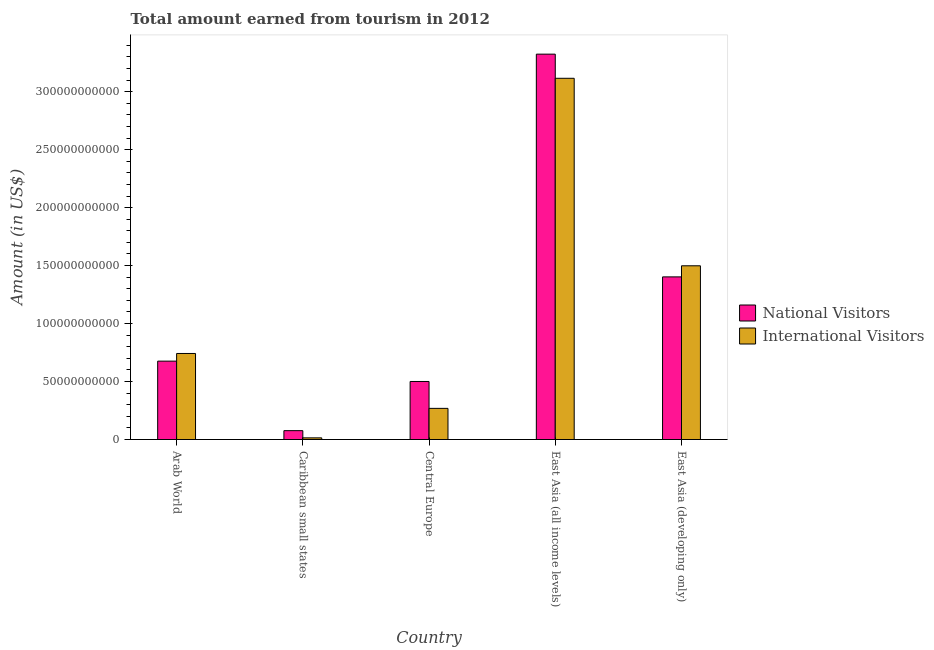How many groups of bars are there?
Offer a very short reply. 5. Are the number of bars on each tick of the X-axis equal?
Provide a succinct answer. Yes. How many bars are there on the 2nd tick from the left?
Provide a short and direct response. 2. What is the label of the 2nd group of bars from the left?
Keep it short and to the point. Caribbean small states. In how many cases, is the number of bars for a given country not equal to the number of legend labels?
Your response must be concise. 0. What is the amount earned from national visitors in East Asia (all income levels)?
Your answer should be very brief. 3.32e+11. Across all countries, what is the maximum amount earned from international visitors?
Offer a terse response. 3.12e+11. Across all countries, what is the minimum amount earned from international visitors?
Give a very brief answer. 1.44e+09. In which country was the amount earned from international visitors maximum?
Ensure brevity in your answer.  East Asia (all income levels). In which country was the amount earned from national visitors minimum?
Ensure brevity in your answer.  Caribbean small states. What is the total amount earned from national visitors in the graph?
Keep it short and to the point. 5.98e+11. What is the difference between the amount earned from international visitors in Arab World and that in East Asia (developing only)?
Keep it short and to the point. -7.56e+1. What is the difference between the amount earned from national visitors in East Asia (all income levels) and the amount earned from international visitors in Central Europe?
Give a very brief answer. 3.05e+11. What is the average amount earned from national visitors per country?
Provide a succinct answer. 1.20e+11. What is the difference between the amount earned from international visitors and amount earned from national visitors in East Asia (developing only)?
Provide a short and direct response. 9.57e+09. In how many countries, is the amount earned from national visitors greater than 330000000000 US$?
Your answer should be compact. 1. What is the ratio of the amount earned from international visitors in East Asia (all income levels) to that in East Asia (developing only)?
Your response must be concise. 2.08. Is the difference between the amount earned from national visitors in Arab World and East Asia (all income levels) greater than the difference between the amount earned from international visitors in Arab World and East Asia (all income levels)?
Your response must be concise. No. What is the difference between the highest and the second highest amount earned from international visitors?
Your response must be concise. 1.62e+11. What is the difference between the highest and the lowest amount earned from national visitors?
Offer a terse response. 3.25e+11. Is the sum of the amount earned from national visitors in Central Europe and East Asia (all income levels) greater than the maximum amount earned from international visitors across all countries?
Offer a terse response. Yes. What does the 1st bar from the left in Caribbean small states represents?
Give a very brief answer. National Visitors. What does the 2nd bar from the right in Central Europe represents?
Your answer should be compact. National Visitors. How many bars are there?
Make the answer very short. 10. Are all the bars in the graph horizontal?
Provide a short and direct response. No. How are the legend labels stacked?
Provide a succinct answer. Vertical. What is the title of the graph?
Offer a terse response. Total amount earned from tourism in 2012. What is the label or title of the X-axis?
Your answer should be very brief. Country. What is the Amount (in US$) of National Visitors in Arab World?
Ensure brevity in your answer.  6.76e+1. What is the Amount (in US$) of International Visitors in Arab World?
Offer a terse response. 7.42e+1. What is the Amount (in US$) in National Visitors in Caribbean small states?
Your response must be concise. 7.65e+09. What is the Amount (in US$) of International Visitors in Caribbean small states?
Offer a very short reply. 1.44e+09. What is the Amount (in US$) of National Visitors in Central Europe?
Provide a short and direct response. 5.01e+1. What is the Amount (in US$) in International Visitors in Central Europe?
Offer a terse response. 2.69e+1. What is the Amount (in US$) of National Visitors in East Asia (all income levels)?
Offer a terse response. 3.32e+11. What is the Amount (in US$) in International Visitors in East Asia (all income levels)?
Provide a short and direct response. 3.12e+11. What is the Amount (in US$) in National Visitors in East Asia (developing only)?
Keep it short and to the point. 1.40e+11. What is the Amount (in US$) in International Visitors in East Asia (developing only)?
Offer a very short reply. 1.50e+11. Across all countries, what is the maximum Amount (in US$) of National Visitors?
Your answer should be compact. 3.32e+11. Across all countries, what is the maximum Amount (in US$) in International Visitors?
Offer a very short reply. 3.12e+11. Across all countries, what is the minimum Amount (in US$) in National Visitors?
Your answer should be compact. 7.65e+09. Across all countries, what is the minimum Amount (in US$) of International Visitors?
Provide a short and direct response. 1.44e+09. What is the total Amount (in US$) of National Visitors in the graph?
Offer a very short reply. 5.98e+11. What is the total Amount (in US$) in International Visitors in the graph?
Offer a very short reply. 5.64e+11. What is the difference between the Amount (in US$) of National Visitors in Arab World and that in Caribbean small states?
Provide a succinct answer. 6.00e+1. What is the difference between the Amount (in US$) in International Visitors in Arab World and that in Caribbean small states?
Keep it short and to the point. 7.28e+1. What is the difference between the Amount (in US$) in National Visitors in Arab World and that in Central Europe?
Your answer should be very brief. 1.75e+1. What is the difference between the Amount (in US$) of International Visitors in Arab World and that in Central Europe?
Your answer should be compact. 4.73e+1. What is the difference between the Amount (in US$) in National Visitors in Arab World and that in East Asia (all income levels)?
Keep it short and to the point. -2.65e+11. What is the difference between the Amount (in US$) in International Visitors in Arab World and that in East Asia (all income levels)?
Your answer should be very brief. -2.37e+11. What is the difference between the Amount (in US$) of National Visitors in Arab World and that in East Asia (developing only)?
Your response must be concise. -7.26e+1. What is the difference between the Amount (in US$) in International Visitors in Arab World and that in East Asia (developing only)?
Make the answer very short. -7.56e+1. What is the difference between the Amount (in US$) in National Visitors in Caribbean small states and that in Central Europe?
Offer a very short reply. -4.24e+1. What is the difference between the Amount (in US$) in International Visitors in Caribbean small states and that in Central Europe?
Your answer should be very brief. -2.54e+1. What is the difference between the Amount (in US$) in National Visitors in Caribbean small states and that in East Asia (all income levels)?
Give a very brief answer. -3.25e+11. What is the difference between the Amount (in US$) in International Visitors in Caribbean small states and that in East Asia (all income levels)?
Your answer should be very brief. -3.10e+11. What is the difference between the Amount (in US$) in National Visitors in Caribbean small states and that in East Asia (developing only)?
Keep it short and to the point. -1.33e+11. What is the difference between the Amount (in US$) of International Visitors in Caribbean small states and that in East Asia (developing only)?
Your answer should be very brief. -1.48e+11. What is the difference between the Amount (in US$) of National Visitors in Central Europe and that in East Asia (all income levels)?
Your response must be concise. -2.82e+11. What is the difference between the Amount (in US$) in International Visitors in Central Europe and that in East Asia (all income levels)?
Your answer should be compact. -2.85e+11. What is the difference between the Amount (in US$) of National Visitors in Central Europe and that in East Asia (developing only)?
Give a very brief answer. -9.02e+1. What is the difference between the Amount (in US$) in International Visitors in Central Europe and that in East Asia (developing only)?
Your response must be concise. -1.23e+11. What is the difference between the Amount (in US$) of National Visitors in East Asia (all income levels) and that in East Asia (developing only)?
Offer a very short reply. 1.92e+11. What is the difference between the Amount (in US$) of International Visitors in East Asia (all income levels) and that in East Asia (developing only)?
Offer a terse response. 1.62e+11. What is the difference between the Amount (in US$) of National Visitors in Arab World and the Amount (in US$) of International Visitors in Caribbean small states?
Offer a very short reply. 6.62e+1. What is the difference between the Amount (in US$) in National Visitors in Arab World and the Amount (in US$) in International Visitors in Central Europe?
Make the answer very short. 4.07e+1. What is the difference between the Amount (in US$) in National Visitors in Arab World and the Amount (in US$) in International Visitors in East Asia (all income levels)?
Make the answer very short. -2.44e+11. What is the difference between the Amount (in US$) in National Visitors in Arab World and the Amount (in US$) in International Visitors in East Asia (developing only)?
Provide a succinct answer. -8.22e+1. What is the difference between the Amount (in US$) of National Visitors in Caribbean small states and the Amount (in US$) of International Visitors in Central Europe?
Offer a terse response. -1.92e+1. What is the difference between the Amount (in US$) of National Visitors in Caribbean small states and the Amount (in US$) of International Visitors in East Asia (all income levels)?
Offer a very short reply. -3.04e+11. What is the difference between the Amount (in US$) of National Visitors in Caribbean small states and the Amount (in US$) of International Visitors in East Asia (developing only)?
Provide a short and direct response. -1.42e+11. What is the difference between the Amount (in US$) in National Visitors in Central Europe and the Amount (in US$) in International Visitors in East Asia (all income levels)?
Offer a terse response. -2.61e+11. What is the difference between the Amount (in US$) in National Visitors in Central Europe and the Amount (in US$) in International Visitors in East Asia (developing only)?
Offer a terse response. -9.98e+1. What is the difference between the Amount (in US$) of National Visitors in East Asia (all income levels) and the Amount (in US$) of International Visitors in East Asia (developing only)?
Keep it short and to the point. 1.83e+11. What is the average Amount (in US$) in National Visitors per country?
Ensure brevity in your answer.  1.20e+11. What is the average Amount (in US$) of International Visitors per country?
Provide a succinct answer. 1.13e+11. What is the difference between the Amount (in US$) of National Visitors and Amount (in US$) of International Visitors in Arab World?
Offer a terse response. -6.60e+09. What is the difference between the Amount (in US$) of National Visitors and Amount (in US$) of International Visitors in Caribbean small states?
Your answer should be very brief. 6.21e+09. What is the difference between the Amount (in US$) in National Visitors and Amount (in US$) in International Visitors in Central Europe?
Your response must be concise. 2.32e+1. What is the difference between the Amount (in US$) in National Visitors and Amount (in US$) in International Visitors in East Asia (all income levels)?
Your answer should be compact. 2.08e+1. What is the difference between the Amount (in US$) of National Visitors and Amount (in US$) of International Visitors in East Asia (developing only)?
Provide a short and direct response. -9.57e+09. What is the ratio of the Amount (in US$) in National Visitors in Arab World to that in Caribbean small states?
Your response must be concise. 8.84. What is the ratio of the Amount (in US$) in International Visitors in Arab World to that in Caribbean small states?
Provide a short and direct response. 51.55. What is the ratio of the Amount (in US$) in National Visitors in Arab World to that in Central Europe?
Your answer should be compact. 1.35. What is the ratio of the Amount (in US$) in International Visitors in Arab World to that in Central Europe?
Offer a terse response. 2.76. What is the ratio of the Amount (in US$) of National Visitors in Arab World to that in East Asia (all income levels)?
Your answer should be very brief. 0.2. What is the ratio of the Amount (in US$) in International Visitors in Arab World to that in East Asia (all income levels)?
Offer a terse response. 0.24. What is the ratio of the Amount (in US$) of National Visitors in Arab World to that in East Asia (developing only)?
Make the answer very short. 0.48. What is the ratio of the Amount (in US$) in International Visitors in Arab World to that in East Asia (developing only)?
Provide a succinct answer. 0.5. What is the ratio of the Amount (in US$) in National Visitors in Caribbean small states to that in Central Europe?
Your answer should be compact. 0.15. What is the ratio of the Amount (in US$) in International Visitors in Caribbean small states to that in Central Europe?
Your answer should be compact. 0.05. What is the ratio of the Amount (in US$) of National Visitors in Caribbean small states to that in East Asia (all income levels)?
Provide a short and direct response. 0.02. What is the ratio of the Amount (in US$) in International Visitors in Caribbean small states to that in East Asia (all income levels)?
Offer a very short reply. 0. What is the ratio of the Amount (in US$) in National Visitors in Caribbean small states to that in East Asia (developing only)?
Offer a very short reply. 0.05. What is the ratio of the Amount (in US$) of International Visitors in Caribbean small states to that in East Asia (developing only)?
Provide a succinct answer. 0.01. What is the ratio of the Amount (in US$) in National Visitors in Central Europe to that in East Asia (all income levels)?
Make the answer very short. 0.15. What is the ratio of the Amount (in US$) in International Visitors in Central Europe to that in East Asia (all income levels)?
Ensure brevity in your answer.  0.09. What is the ratio of the Amount (in US$) of National Visitors in Central Europe to that in East Asia (developing only)?
Ensure brevity in your answer.  0.36. What is the ratio of the Amount (in US$) of International Visitors in Central Europe to that in East Asia (developing only)?
Offer a very short reply. 0.18. What is the ratio of the Amount (in US$) in National Visitors in East Asia (all income levels) to that in East Asia (developing only)?
Give a very brief answer. 2.37. What is the ratio of the Amount (in US$) in International Visitors in East Asia (all income levels) to that in East Asia (developing only)?
Your answer should be compact. 2.08. What is the difference between the highest and the second highest Amount (in US$) of National Visitors?
Your answer should be very brief. 1.92e+11. What is the difference between the highest and the second highest Amount (in US$) in International Visitors?
Your answer should be compact. 1.62e+11. What is the difference between the highest and the lowest Amount (in US$) of National Visitors?
Your answer should be very brief. 3.25e+11. What is the difference between the highest and the lowest Amount (in US$) in International Visitors?
Your response must be concise. 3.10e+11. 